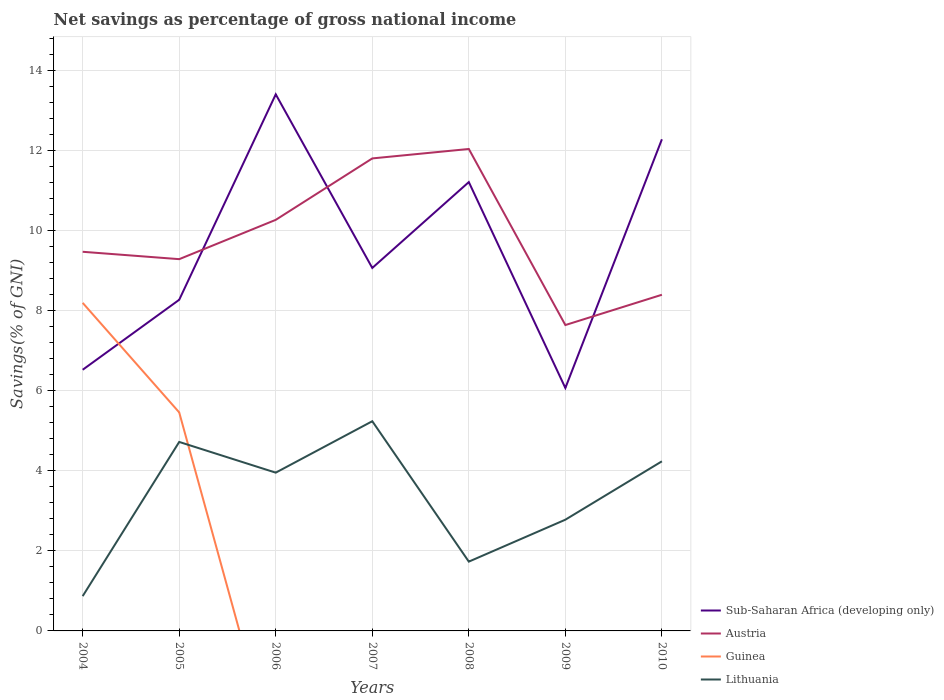How many different coloured lines are there?
Your response must be concise. 4. Is the number of lines equal to the number of legend labels?
Provide a short and direct response. No. Across all years, what is the maximum total savings in Lithuania?
Give a very brief answer. 0.87. What is the total total savings in Sub-Saharan Africa (developing only) in the graph?
Provide a succinct answer. 5.15. What is the difference between the highest and the second highest total savings in Sub-Saharan Africa (developing only)?
Offer a very short reply. 7.34. What is the difference between the highest and the lowest total savings in Sub-Saharan Africa (developing only)?
Make the answer very short. 3. How many lines are there?
Give a very brief answer. 4. How many years are there in the graph?
Provide a succinct answer. 7. What is the difference between two consecutive major ticks on the Y-axis?
Your response must be concise. 2. Are the values on the major ticks of Y-axis written in scientific E-notation?
Offer a very short reply. No. How many legend labels are there?
Offer a very short reply. 4. How are the legend labels stacked?
Your answer should be very brief. Vertical. What is the title of the graph?
Provide a succinct answer. Net savings as percentage of gross national income. Does "Lao PDR" appear as one of the legend labels in the graph?
Ensure brevity in your answer.  No. What is the label or title of the Y-axis?
Provide a succinct answer. Savings(% of GNI). What is the Savings(% of GNI) of Sub-Saharan Africa (developing only) in 2004?
Your answer should be compact. 6.53. What is the Savings(% of GNI) of Austria in 2004?
Offer a terse response. 9.48. What is the Savings(% of GNI) in Guinea in 2004?
Your answer should be compact. 8.2. What is the Savings(% of GNI) of Lithuania in 2004?
Ensure brevity in your answer.  0.87. What is the Savings(% of GNI) of Sub-Saharan Africa (developing only) in 2005?
Your response must be concise. 8.28. What is the Savings(% of GNI) in Austria in 2005?
Your answer should be compact. 9.29. What is the Savings(% of GNI) in Guinea in 2005?
Provide a succinct answer. 5.46. What is the Savings(% of GNI) in Lithuania in 2005?
Make the answer very short. 4.72. What is the Savings(% of GNI) in Sub-Saharan Africa (developing only) in 2006?
Provide a succinct answer. 13.41. What is the Savings(% of GNI) of Austria in 2006?
Your answer should be very brief. 10.27. What is the Savings(% of GNI) in Lithuania in 2006?
Provide a short and direct response. 3.96. What is the Savings(% of GNI) in Sub-Saharan Africa (developing only) in 2007?
Provide a succinct answer. 9.07. What is the Savings(% of GNI) of Austria in 2007?
Provide a short and direct response. 11.81. What is the Savings(% of GNI) of Guinea in 2007?
Your answer should be compact. 0. What is the Savings(% of GNI) in Lithuania in 2007?
Your answer should be compact. 5.24. What is the Savings(% of GNI) in Sub-Saharan Africa (developing only) in 2008?
Make the answer very short. 11.22. What is the Savings(% of GNI) in Austria in 2008?
Offer a terse response. 12.04. What is the Savings(% of GNI) of Lithuania in 2008?
Ensure brevity in your answer.  1.73. What is the Savings(% of GNI) in Sub-Saharan Africa (developing only) in 2009?
Provide a succinct answer. 6.07. What is the Savings(% of GNI) of Austria in 2009?
Your response must be concise. 7.64. What is the Savings(% of GNI) in Lithuania in 2009?
Provide a short and direct response. 2.78. What is the Savings(% of GNI) of Sub-Saharan Africa (developing only) in 2010?
Your response must be concise. 12.29. What is the Savings(% of GNI) in Austria in 2010?
Your answer should be very brief. 8.4. What is the Savings(% of GNI) in Guinea in 2010?
Give a very brief answer. 0. What is the Savings(% of GNI) of Lithuania in 2010?
Your answer should be very brief. 4.24. Across all years, what is the maximum Savings(% of GNI) of Sub-Saharan Africa (developing only)?
Your answer should be very brief. 13.41. Across all years, what is the maximum Savings(% of GNI) of Austria?
Provide a short and direct response. 12.04. Across all years, what is the maximum Savings(% of GNI) in Guinea?
Your response must be concise. 8.2. Across all years, what is the maximum Savings(% of GNI) of Lithuania?
Provide a succinct answer. 5.24. Across all years, what is the minimum Savings(% of GNI) of Sub-Saharan Africa (developing only)?
Ensure brevity in your answer.  6.07. Across all years, what is the minimum Savings(% of GNI) of Austria?
Keep it short and to the point. 7.64. Across all years, what is the minimum Savings(% of GNI) in Guinea?
Ensure brevity in your answer.  0. Across all years, what is the minimum Savings(% of GNI) in Lithuania?
Ensure brevity in your answer.  0.87. What is the total Savings(% of GNI) in Sub-Saharan Africa (developing only) in the graph?
Make the answer very short. 66.86. What is the total Savings(% of GNI) of Austria in the graph?
Your answer should be very brief. 68.94. What is the total Savings(% of GNI) of Guinea in the graph?
Keep it short and to the point. 13.66. What is the total Savings(% of GNI) of Lithuania in the graph?
Ensure brevity in your answer.  23.54. What is the difference between the Savings(% of GNI) of Sub-Saharan Africa (developing only) in 2004 and that in 2005?
Ensure brevity in your answer.  -1.75. What is the difference between the Savings(% of GNI) of Austria in 2004 and that in 2005?
Provide a succinct answer. 0.18. What is the difference between the Savings(% of GNI) in Guinea in 2004 and that in 2005?
Offer a very short reply. 2.74. What is the difference between the Savings(% of GNI) of Lithuania in 2004 and that in 2005?
Offer a very short reply. -3.85. What is the difference between the Savings(% of GNI) in Sub-Saharan Africa (developing only) in 2004 and that in 2006?
Keep it short and to the point. -6.88. What is the difference between the Savings(% of GNI) of Austria in 2004 and that in 2006?
Give a very brief answer. -0.8. What is the difference between the Savings(% of GNI) in Lithuania in 2004 and that in 2006?
Provide a short and direct response. -3.09. What is the difference between the Savings(% of GNI) of Sub-Saharan Africa (developing only) in 2004 and that in 2007?
Give a very brief answer. -2.54. What is the difference between the Savings(% of GNI) in Austria in 2004 and that in 2007?
Provide a short and direct response. -2.33. What is the difference between the Savings(% of GNI) of Lithuania in 2004 and that in 2007?
Offer a very short reply. -4.37. What is the difference between the Savings(% of GNI) of Sub-Saharan Africa (developing only) in 2004 and that in 2008?
Give a very brief answer. -4.69. What is the difference between the Savings(% of GNI) of Austria in 2004 and that in 2008?
Keep it short and to the point. -2.57. What is the difference between the Savings(% of GNI) of Lithuania in 2004 and that in 2008?
Make the answer very short. -0.86. What is the difference between the Savings(% of GNI) of Sub-Saharan Africa (developing only) in 2004 and that in 2009?
Give a very brief answer. 0.46. What is the difference between the Savings(% of GNI) in Austria in 2004 and that in 2009?
Ensure brevity in your answer.  1.83. What is the difference between the Savings(% of GNI) in Lithuania in 2004 and that in 2009?
Make the answer very short. -1.91. What is the difference between the Savings(% of GNI) of Sub-Saharan Africa (developing only) in 2004 and that in 2010?
Offer a terse response. -5.76. What is the difference between the Savings(% of GNI) in Austria in 2004 and that in 2010?
Offer a terse response. 1.07. What is the difference between the Savings(% of GNI) in Lithuania in 2004 and that in 2010?
Offer a very short reply. -3.37. What is the difference between the Savings(% of GNI) in Sub-Saharan Africa (developing only) in 2005 and that in 2006?
Your answer should be very brief. -5.13. What is the difference between the Savings(% of GNI) of Austria in 2005 and that in 2006?
Provide a short and direct response. -0.98. What is the difference between the Savings(% of GNI) of Lithuania in 2005 and that in 2006?
Ensure brevity in your answer.  0.77. What is the difference between the Savings(% of GNI) of Sub-Saharan Africa (developing only) in 2005 and that in 2007?
Offer a terse response. -0.8. What is the difference between the Savings(% of GNI) of Austria in 2005 and that in 2007?
Your response must be concise. -2.52. What is the difference between the Savings(% of GNI) of Lithuania in 2005 and that in 2007?
Your answer should be compact. -0.52. What is the difference between the Savings(% of GNI) in Sub-Saharan Africa (developing only) in 2005 and that in 2008?
Your answer should be compact. -2.94. What is the difference between the Savings(% of GNI) of Austria in 2005 and that in 2008?
Offer a very short reply. -2.75. What is the difference between the Savings(% of GNI) in Lithuania in 2005 and that in 2008?
Give a very brief answer. 2.99. What is the difference between the Savings(% of GNI) in Sub-Saharan Africa (developing only) in 2005 and that in 2009?
Your answer should be compact. 2.21. What is the difference between the Savings(% of GNI) of Austria in 2005 and that in 2009?
Give a very brief answer. 1.65. What is the difference between the Savings(% of GNI) in Lithuania in 2005 and that in 2009?
Provide a succinct answer. 1.94. What is the difference between the Savings(% of GNI) of Sub-Saharan Africa (developing only) in 2005 and that in 2010?
Ensure brevity in your answer.  -4.01. What is the difference between the Savings(% of GNI) of Austria in 2005 and that in 2010?
Your answer should be compact. 0.89. What is the difference between the Savings(% of GNI) of Lithuania in 2005 and that in 2010?
Offer a terse response. 0.48. What is the difference between the Savings(% of GNI) in Sub-Saharan Africa (developing only) in 2006 and that in 2007?
Keep it short and to the point. 4.34. What is the difference between the Savings(% of GNI) in Austria in 2006 and that in 2007?
Provide a succinct answer. -1.54. What is the difference between the Savings(% of GNI) in Lithuania in 2006 and that in 2007?
Provide a succinct answer. -1.29. What is the difference between the Savings(% of GNI) in Sub-Saharan Africa (developing only) in 2006 and that in 2008?
Offer a terse response. 2.19. What is the difference between the Savings(% of GNI) in Austria in 2006 and that in 2008?
Offer a terse response. -1.77. What is the difference between the Savings(% of GNI) of Lithuania in 2006 and that in 2008?
Your answer should be compact. 2.22. What is the difference between the Savings(% of GNI) in Sub-Saharan Africa (developing only) in 2006 and that in 2009?
Provide a succinct answer. 7.34. What is the difference between the Savings(% of GNI) in Austria in 2006 and that in 2009?
Your response must be concise. 2.63. What is the difference between the Savings(% of GNI) of Lithuania in 2006 and that in 2009?
Your response must be concise. 1.18. What is the difference between the Savings(% of GNI) in Sub-Saharan Africa (developing only) in 2006 and that in 2010?
Give a very brief answer. 1.12. What is the difference between the Savings(% of GNI) in Austria in 2006 and that in 2010?
Your answer should be very brief. 1.87. What is the difference between the Savings(% of GNI) in Lithuania in 2006 and that in 2010?
Provide a short and direct response. -0.28. What is the difference between the Savings(% of GNI) of Sub-Saharan Africa (developing only) in 2007 and that in 2008?
Offer a terse response. -2.15. What is the difference between the Savings(% of GNI) in Austria in 2007 and that in 2008?
Offer a terse response. -0.24. What is the difference between the Savings(% of GNI) of Lithuania in 2007 and that in 2008?
Keep it short and to the point. 3.51. What is the difference between the Savings(% of GNI) in Sub-Saharan Africa (developing only) in 2007 and that in 2009?
Provide a short and direct response. 3. What is the difference between the Savings(% of GNI) of Austria in 2007 and that in 2009?
Keep it short and to the point. 4.16. What is the difference between the Savings(% of GNI) of Lithuania in 2007 and that in 2009?
Your answer should be compact. 2.46. What is the difference between the Savings(% of GNI) of Sub-Saharan Africa (developing only) in 2007 and that in 2010?
Ensure brevity in your answer.  -3.22. What is the difference between the Savings(% of GNI) of Austria in 2007 and that in 2010?
Your response must be concise. 3.41. What is the difference between the Savings(% of GNI) of Sub-Saharan Africa (developing only) in 2008 and that in 2009?
Ensure brevity in your answer.  5.15. What is the difference between the Savings(% of GNI) in Austria in 2008 and that in 2009?
Offer a terse response. 4.4. What is the difference between the Savings(% of GNI) of Lithuania in 2008 and that in 2009?
Ensure brevity in your answer.  -1.05. What is the difference between the Savings(% of GNI) in Sub-Saharan Africa (developing only) in 2008 and that in 2010?
Offer a terse response. -1.07. What is the difference between the Savings(% of GNI) in Austria in 2008 and that in 2010?
Provide a succinct answer. 3.64. What is the difference between the Savings(% of GNI) of Lithuania in 2008 and that in 2010?
Your response must be concise. -2.51. What is the difference between the Savings(% of GNI) of Sub-Saharan Africa (developing only) in 2009 and that in 2010?
Keep it short and to the point. -6.22. What is the difference between the Savings(% of GNI) of Austria in 2009 and that in 2010?
Ensure brevity in your answer.  -0.76. What is the difference between the Savings(% of GNI) of Lithuania in 2009 and that in 2010?
Ensure brevity in your answer.  -1.46. What is the difference between the Savings(% of GNI) of Sub-Saharan Africa (developing only) in 2004 and the Savings(% of GNI) of Austria in 2005?
Give a very brief answer. -2.76. What is the difference between the Savings(% of GNI) of Sub-Saharan Africa (developing only) in 2004 and the Savings(% of GNI) of Guinea in 2005?
Ensure brevity in your answer.  1.07. What is the difference between the Savings(% of GNI) in Sub-Saharan Africa (developing only) in 2004 and the Savings(% of GNI) in Lithuania in 2005?
Keep it short and to the point. 1.8. What is the difference between the Savings(% of GNI) of Austria in 2004 and the Savings(% of GNI) of Guinea in 2005?
Offer a terse response. 4.01. What is the difference between the Savings(% of GNI) of Austria in 2004 and the Savings(% of GNI) of Lithuania in 2005?
Offer a terse response. 4.75. What is the difference between the Savings(% of GNI) in Guinea in 2004 and the Savings(% of GNI) in Lithuania in 2005?
Your answer should be very brief. 3.48. What is the difference between the Savings(% of GNI) of Sub-Saharan Africa (developing only) in 2004 and the Savings(% of GNI) of Austria in 2006?
Make the answer very short. -3.75. What is the difference between the Savings(% of GNI) of Sub-Saharan Africa (developing only) in 2004 and the Savings(% of GNI) of Lithuania in 2006?
Provide a short and direct response. 2.57. What is the difference between the Savings(% of GNI) in Austria in 2004 and the Savings(% of GNI) in Lithuania in 2006?
Provide a succinct answer. 5.52. What is the difference between the Savings(% of GNI) in Guinea in 2004 and the Savings(% of GNI) in Lithuania in 2006?
Offer a terse response. 4.24. What is the difference between the Savings(% of GNI) in Sub-Saharan Africa (developing only) in 2004 and the Savings(% of GNI) in Austria in 2007?
Give a very brief answer. -5.28. What is the difference between the Savings(% of GNI) in Sub-Saharan Africa (developing only) in 2004 and the Savings(% of GNI) in Lithuania in 2007?
Your answer should be compact. 1.29. What is the difference between the Savings(% of GNI) of Austria in 2004 and the Savings(% of GNI) of Lithuania in 2007?
Your response must be concise. 4.23. What is the difference between the Savings(% of GNI) of Guinea in 2004 and the Savings(% of GNI) of Lithuania in 2007?
Provide a short and direct response. 2.96. What is the difference between the Savings(% of GNI) of Sub-Saharan Africa (developing only) in 2004 and the Savings(% of GNI) of Austria in 2008?
Offer a terse response. -5.52. What is the difference between the Savings(% of GNI) of Sub-Saharan Africa (developing only) in 2004 and the Savings(% of GNI) of Lithuania in 2008?
Offer a terse response. 4.8. What is the difference between the Savings(% of GNI) of Austria in 2004 and the Savings(% of GNI) of Lithuania in 2008?
Your answer should be very brief. 7.74. What is the difference between the Savings(% of GNI) in Guinea in 2004 and the Savings(% of GNI) in Lithuania in 2008?
Provide a short and direct response. 6.47. What is the difference between the Savings(% of GNI) in Sub-Saharan Africa (developing only) in 2004 and the Savings(% of GNI) in Austria in 2009?
Keep it short and to the point. -1.12. What is the difference between the Savings(% of GNI) of Sub-Saharan Africa (developing only) in 2004 and the Savings(% of GNI) of Lithuania in 2009?
Give a very brief answer. 3.75. What is the difference between the Savings(% of GNI) of Austria in 2004 and the Savings(% of GNI) of Lithuania in 2009?
Your answer should be compact. 6.7. What is the difference between the Savings(% of GNI) of Guinea in 2004 and the Savings(% of GNI) of Lithuania in 2009?
Make the answer very short. 5.42. What is the difference between the Savings(% of GNI) of Sub-Saharan Africa (developing only) in 2004 and the Savings(% of GNI) of Austria in 2010?
Offer a terse response. -1.87. What is the difference between the Savings(% of GNI) in Sub-Saharan Africa (developing only) in 2004 and the Savings(% of GNI) in Lithuania in 2010?
Provide a short and direct response. 2.29. What is the difference between the Savings(% of GNI) of Austria in 2004 and the Savings(% of GNI) of Lithuania in 2010?
Offer a very short reply. 5.24. What is the difference between the Savings(% of GNI) of Guinea in 2004 and the Savings(% of GNI) of Lithuania in 2010?
Keep it short and to the point. 3.96. What is the difference between the Savings(% of GNI) in Sub-Saharan Africa (developing only) in 2005 and the Savings(% of GNI) in Austria in 2006?
Provide a short and direct response. -2. What is the difference between the Savings(% of GNI) in Sub-Saharan Africa (developing only) in 2005 and the Savings(% of GNI) in Lithuania in 2006?
Provide a succinct answer. 4.32. What is the difference between the Savings(% of GNI) in Austria in 2005 and the Savings(% of GNI) in Lithuania in 2006?
Give a very brief answer. 5.34. What is the difference between the Savings(% of GNI) in Guinea in 2005 and the Savings(% of GNI) in Lithuania in 2006?
Your answer should be very brief. 1.51. What is the difference between the Savings(% of GNI) of Sub-Saharan Africa (developing only) in 2005 and the Savings(% of GNI) of Austria in 2007?
Keep it short and to the point. -3.53. What is the difference between the Savings(% of GNI) in Sub-Saharan Africa (developing only) in 2005 and the Savings(% of GNI) in Lithuania in 2007?
Provide a succinct answer. 3.04. What is the difference between the Savings(% of GNI) in Austria in 2005 and the Savings(% of GNI) in Lithuania in 2007?
Offer a very short reply. 4.05. What is the difference between the Savings(% of GNI) in Guinea in 2005 and the Savings(% of GNI) in Lithuania in 2007?
Make the answer very short. 0.22. What is the difference between the Savings(% of GNI) of Sub-Saharan Africa (developing only) in 2005 and the Savings(% of GNI) of Austria in 2008?
Your response must be concise. -3.77. What is the difference between the Savings(% of GNI) in Sub-Saharan Africa (developing only) in 2005 and the Savings(% of GNI) in Lithuania in 2008?
Provide a short and direct response. 6.54. What is the difference between the Savings(% of GNI) in Austria in 2005 and the Savings(% of GNI) in Lithuania in 2008?
Your answer should be very brief. 7.56. What is the difference between the Savings(% of GNI) of Guinea in 2005 and the Savings(% of GNI) of Lithuania in 2008?
Offer a terse response. 3.73. What is the difference between the Savings(% of GNI) in Sub-Saharan Africa (developing only) in 2005 and the Savings(% of GNI) in Austria in 2009?
Your response must be concise. 0.63. What is the difference between the Savings(% of GNI) of Sub-Saharan Africa (developing only) in 2005 and the Savings(% of GNI) of Lithuania in 2009?
Provide a succinct answer. 5.5. What is the difference between the Savings(% of GNI) of Austria in 2005 and the Savings(% of GNI) of Lithuania in 2009?
Your answer should be very brief. 6.51. What is the difference between the Savings(% of GNI) in Guinea in 2005 and the Savings(% of GNI) in Lithuania in 2009?
Make the answer very short. 2.68. What is the difference between the Savings(% of GNI) in Sub-Saharan Africa (developing only) in 2005 and the Savings(% of GNI) in Austria in 2010?
Make the answer very short. -0.13. What is the difference between the Savings(% of GNI) of Sub-Saharan Africa (developing only) in 2005 and the Savings(% of GNI) of Lithuania in 2010?
Provide a succinct answer. 4.04. What is the difference between the Savings(% of GNI) of Austria in 2005 and the Savings(% of GNI) of Lithuania in 2010?
Your response must be concise. 5.05. What is the difference between the Savings(% of GNI) in Guinea in 2005 and the Savings(% of GNI) in Lithuania in 2010?
Your answer should be compact. 1.22. What is the difference between the Savings(% of GNI) of Sub-Saharan Africa (developing only) in 2006 and the Savings(% of GNI) of Austria in 2007?
Give a very brief answer. 1.6. What is the difference between the Savings(% of GNI) in Sub-Saharan Africa (developing only) in 2006 and the Savings(% of GNI) in Lithuania in 2007?
Make the answer very short. 8.17. What is the difference between the Savings(% of GNI) of Austria in 2006 and the Savings(% of GNI) of Lithuania in 2007?
Make the answer very short. 5.03. What is the difference between the Savings(% of GNI) in Sub-Saharan Africa (developing only) in 2006 and the Savings(% of GNI) in Austria in 2008?
Ensure brevity in your answer.  1.37. What is the difference between the Savings(% of GNI) in Sub-Saharan Africa (developing only) in 2006 and the Savings(% of GNI) in Lithuania in 2008?
Offer a very short reply. 11.68. What is the difference between the Savings(% of GNI) in Austria in 2006 and the Savings(% of GNI) in Lithuania in 2008?
Your answer should be very brief. 8.54. What is the difference between the Savings(% of GNI) in Sub-Saharan Africa (developing only) in 2006 and the Savings(% of GNI) in Austria in 2009?
Your response must be concise. 5.77. What is the difference between the Savings(% of GNI) of Sub-Saharan Africa (developing only) in 2006 and the Savings(% of GNI) of Lithuania in 2009?
Provide a succinct answer. 10.63. What is the difference between the Savings(% of GNI) of Austria in 2006 and the Savings(% of GNI) of Lithuania in 2009?
Keep it short and to the point. 7.49. What is the difference between the Savings(% of GNI) in Sub-Saharan Africa (developing only) in 2006 and the Savings(% of GNI) in Austria in 2010?
Make the answer very short. 5.01. What is the difference between the Savings(% of GNI) of Sub-Saharan Africa (developing only) in 2006 and the Savings(% of GNI) of Lithuania in 2010?
Make the answer very short. 9.17. What is the difference between the Savings(% of GNI) of Austria in 2006 and the Savings(% of GNI) of Lithuania in 2010?
Ensure brevity in your answer.  6.03. What is the difference between the Savings(% of GNI) in Sub-Saharan Africa (developing only) in 2007 and the Savings(% of GNI) in Austria in 2008?
Give a very brief answer. -2.97. What is the difference between the Savings(% of GNI) of Sub-Saharan Africa (developing only) in 2007 and the Savings(% of GNI) of Lithuania in 2008?
Give a very brief answer. 7.34. What is the difference between the Savings(% of GNI) in Austria in 2007 and the Savings(% of GNI) in Lithuania in 2008?
Give a very brief answer. 10.08. What is the difference between the Savings(% of GNI) in Sub-Saharan Africa (developing only) in 2007 and the Savings(% of GNI) in Austria in 2009?
Your answer should be compact. 1.43. What is the difference between the Savings(% of GNI) of Sub-Saharan Africa (developing only) in 2007 and the Savings(% of GNI) of Lithuania in 2009?
Give a very brief answer. 6.29. What is the difference between the Savings(% of GNI) in Austria in 2007 and the Savings(% of GNI) in Lithuania in 2009?
Keep it short and to the point. 9.03. What is the difference between the Savings(% of GNI) in Sub-Saharan Africa (developing only) in 2007 and the Savings(% of GNI) in Austria in 2010?
Your answer should be compact. 0.67. What is the difference between the Savings(% of GNI) of Sub-Saharan Africa (developing only) in 2007 and the Savings(% of GNI) of Lithuania in 2010?
Keep it short and to the point. 4.83. What is the difference between the Savings(% of GNI) of Austria in 2007 and the Savings(% of GNI) of Lithuania in 2010?
Your response must be concise. 7.57. What is the difference between the Savings(% of GNI) of Sub-Saharan Africa (developing only) in 2008 and the Savings(% of GNI) of Austria in 2009?
Make the answer very short. 3.57. What is the difference between the Savings(% of GNI) of Sub-Saharan Africa (developing only) in 2008 and the Savings(% of GNI) of Lithuania in 2009?
Provide a succinct answer. 8.44. What is the difference between the Savings(% of GNI) in Austria in 2008 and the Savings(% of GNI) in Lithuania in 2009?
Make the answer very short. 9.26. What is the difference between the Savings(% of GNI) in Sub-Saharan Africa (developing only) in 2008 and the Savings(% of GNI) in Austria in 2010?
Provide a short and direct response. 2.82. What is the difference between the Savings(% of GNI) of Sub-Saharan Africa (developing only) in 2008 and the Savings(% of GNI) of Lithuania in 2010?
Your answer should be very brief. 6.98. What is the difference between the Savings(% of GNI) in Austria in 2008 and the Savings(% of GNI) in Lithuania in 2010?
Provide a succinct answer. 7.81. What is the difference between the Savings(% of GNI) in Sub-Saharan Africa (developing only) in 2009 and the Savings(% of GNI) in Austria in 2010?
Provide a short and direct response. -2.33. What is the difference between the Savings(% of GNI) in Sub-Saharan Africa (developing only) in 2009 and the Savings(% of GNI) in Lithuania in 2010?
Keep it short and to the point. 1.83. What is the difference between the Savings(% of GNI) in Austria in 2009 and the Savings(% of GNI) in Lithuania in 2010?
Provide a short and direct response. 3.41. What is the average Savings(% of GNI) in Sub-Saharan Africa (developing only) per year?
Provide a short and direct response. 9.55. What is the average Savings(% of GNI) in Austria per year?
Keep it short and to the point. 9.85. What is the average Savings(% of GNI) in Guinea per year?
Your answer should be very brief. 1.95. What is the average Savings(% of GNI) in Lithuania per year?
Your answer should be compact. 3.36. In the year 2004, what is the difference between the Savings(% of GNI) in Sub-Saharan Africa (developing only) and Savings(% of GNI) in Austria?
Ensure brevity in your answer.  -2.95. In the year 2004, what is the difference between the Savings(% of GNI) of Sub-Saharan Africa (developing only) and Savings(% of GNI) of Guinea?
Your answer should be compact. -1.67. In the year 2004, what is the difference between the Savings(% of GNI) of Sub-Saharan Africa (developing only) and Savings(% of GNI) of Lithuania?
Offer a terse response. 5.66. In the year 2004, what is the difference between the Savings(% of GNI) in Austria and Savings(% of GNI) in Guinea?
Give a very brief answer. 1.28. In the year 2004, what is the difference between the Savings(% of GNI) of Austria and Savings(% of GNI) of Lithuania?
Provide a short and direct response. 8.61. In the year 2004, what is the difference between the Savings(% of GNI) in Guinea and Savings(% of GNI) in Lithuania?
Your answer should be very brief. 7.33. In the year 2005, what is the difference between the Savings(% of GNI) in Sub-Saharan Africa (developing only) and Savings(% of GNI) in Austria?
Give a very brief answer. -1.01. In the year 2005, what is the difference between the Savings(% of GNI) in Sub-Saharan Africa (developing only) and Savings(% of GNI) in Guinea?
Ensure brevity in your answer.  2.82. In the year 2005, what is the difference between the Savings(% of GNI) of Sub-Saharan Africa (developing only) and Savings(% of GNI) of Lithuania?
Keep it short and to the point. 3.55. In the year 2005, what is the difference between the Savings(% of GNI) in Austria and Savings(% of GNI) in Guinea?
Offer a terse response. 3.83. In the year 2005, what is the difference between the Savings(% of GNI) of Austria and Savings(% of GNI) of Lithuania?
Provide a succinct answer. 4.57. In the year 2005, what is the difference between the Savings(% of GNI) of Guinea and Savings(% of GNI) of Lithuania?
Make the answer very short. 0.74. In the year 2006, what is the difference between the Savings(% of GNI) in Sub-Saharan Africa (developing only) and Savings(% of GNI) in Austria?
Give a very brief answer. 3.14. In the year 2006, what is the difference between the Savings(% of GNI) of Sub-Saharan Africa (developing only) and Savings(% of GNI) of Lithuania?
Provide a succinct answer. 9.45. In the year 2006, what is the difference between the Savings(% of GNI) in Austria and Savings(% of GNI) in Lithuania?
Make the answer very short. 6.32. In the year 2007, what is the difference between the Savings(% of GNI) of Sub-Saharan Africa (developing only) and Savings(% of GNI) of Austria?
Keep it short and to the point. -2.74. In the year 2007, what is the difference between the Savings(% of GNI) of Sub-Saharan Africa (developing only) and Savings(% of GNI) of Lithuania?
Offer a very short reply. 3.83. In the year 2007, what is the difference between the Savings(% of GNI) of Austria and Savings(% of GNI) of Lithuania?
Your response must be concise. 6.57. In the year 2008, what is the difference between the Savings(% of GNI) in Sub-Saharan Africa (developing only) and Savings(% of GNI) in Austria?
Provide a succinct answer. -0.83. In the year 2008, what is the difference between the Savings(% of GNI) in Sub-Saharan Africa (developing only) and Savings(% of GNI) in Lithuania?
Your answer should be very brief. 9.49. In the year 2008, what is the difference between the Savings(% of GNI) of Austria and Savings(% of GNI) of Lithuania?
Your answer should be compact. 10.31. In the year 2009, what is the difference between the Savings(% of GNI) of Sub-Saharan Africa (developing only) and Savings(% of GNI) of Austria?
Provide a short and direct response. -1.57. In the year 2009, what is the difference between the Savings(% of GNI) in Sub-Saharan Africa (developing only) and Savings(% of GNI) in Lithuania?
Offer a very short reply. 3.29. In the year 2009, what is the difference between the Savings(% of GNI) of Austria and Savings(% of GNI) of Lithuania?
Offer a terse response. 4.86. In the year 2010, what is the difference between the Savings(% of GNI) in Sub-Saharan Africa (developing only) and Savings(% of GNI) in Austria?
Provide a succinct answer. 3.89. In the year 2010, what is the difference between the Savings(% of GNI) of Sub-Saharan Africa (developing only) and Savings(% of GNI) of Lithuania?
Make the answer very short. 8.05. In the year 2010, what is the difference between the Savings(% of GNI) of Austria and Savings(% of GNI) of Lithuania?
Provide a succinct answer. 4.16. What is the ratio of the Savings(% of GNI) in Sub-Saharan Africa (developing only) in 2004 to that in 2005?
Your answer should be very brief. 0.79. What is the ratio of the Savings(% of GNI) of Austria in 2004 to that in 2005?
Offer a terse response. 1.02. What is the ratio of the Savings(% of GNI) of Guinea in 2004 to that in 2005?
Make the answer very short. 1.5. What is the ratio of the Savings(% of GNI) of Lithuania in 2004 to that in 2005?
Your answer should be compact. 0.18. What is the ratio of the Savings(% of GNI) of Sub-Saharan Africa (developing only) in 2004 to that in 2006?
Your answer should be compact. 0.49. What is the ratio of the Savings(% of GNI) in Austria in 2004 to that in 2006?
Provide a short and direct response. 0.92. What is the ratio of the Savings(% of GNI) of Lithuania in 2004 to that in 2006?
Provide a short and direct response. 0.22. What is the ratio of the Savings(% of GNI) of Sub-Saharan Africa (developing only) in 2004 to that in 2007?
Offer a terse response. 0.72. What is the ratio of the Savings(% of GNI) of Austria in 2004 to that in 2007?
Your response must be concise. 0.8. What is the ratio of the Savings(% of GNI) of Lithuania in 2004 to that in 2007?
Your response must be concise. 0.17. What is the ratio of the Savings(% of GNI) in Sub-Saharan Africa (developing only) in 2004 to that in 2008?
Your response must be concise. 0.58. What is the ratio of the Savings(% of GNI) in Austria in 2004 to that in 2008?
Make the answer very short. 0.79. What is the ratio of the Savings(% of GNI) in Lithuania in 2004 to that in 2008?
Provide a succinct answer. 0.5. What is the ratio of the Savings(% of GNI) in Sub-Saharan Africa (developing only) in 2004 to that in 2009?
Your answer should be very brief. 1.08. What is the ratio of the Savings(% of GNI) of Austria in 2004 to that in 2009?
Keep it short and to the point. 1.24. What is the ratio of the Savings(% of GNI) in Lithuania in 2004 to that in 2009?
Your answer should be very brief. 0.31. What is the ratio of the Savings(% of GNI) of Sub-Saharan Africa (developing only) in 2004 to that in 2010?
Offer a terse response. 0.53. What is the ratio of the Savings(% of GNI) of Austria in 2004 to that in 2010?
Your answer should be very brief. 1.13. What is the ratio of the Savings(% of GNI) in Lithuania in 2004 to that in 2010?
Offer a very short reply. 0.2. What is the ratio of the Savings(% of GNI) in Sub-Saharan Africa (developing only) in 2005 to that in 2006?
Your answer should be very brief. 0.62. What is the ratio of the Savings(% of GNI) of Austria in 2005 to that in 2006?
Your answer should be compact. 0.9. What is the ratio of the Savings(% of GNI) of Lithuania in 2005 to that in 2006?
Your answer should be very brief. 1.19. What is the ratio of the Savings(% of GNI) of Sub-Saharan Africa (developing only) in 2005 to that in 2007?
Keep it short and to the point. 0.91. What is the ratio of the Savings(% of GNI) in Austria in 2005 to that in 2007?
Your response must be concise. 0.79. What is the ratio of the Savings(% of GNI) in Lithuania in 2005 to that in 2007?
Give a very brief answer. 0.9. What is the ratio of the Savings(% of GNI) in Sub-Saharan Africa (developing only) in 2005 to that in 2008?
Offer a very short reply. 0.74. What is the ratio of the Savings(% of GNI) of Austria in 2005 to that in 2008?
Your response must be concise. 0.77. What is the ratio of the Savings(% of GNI) in Lithuania in 2005 to that in 2008?
Make the answer very short. 2.73. What is the ratio of the Savings(% of GNI) in Sub-Saharan Africa (developing only) in 2005 to that in 2009?
Give a very brief answer. 1.36. What is the ratio of the Savings(% of GNI) in Austria in 2005 to that in 2009?
Your answer should be compact. 1.22. What is the ratio of the Savings(% of GNI) of Lithuania in 2005 to that in 2009?
Make the answer very short. 1.7. What is the ratio of the Savings(% of GNI) of Sub-Saharan Africa (developing only) in 2005 to that in 2010?
Your answer should be compact. 0.67. What is the ratio of the Savings(% of GNI) in Austria in 2005 to that in 2010?
Ensure brevity in your answer.  1.11. What is the ratio of the Savings(% of GNI) of Lithuania in 2005 to that in 2010?
Provide a succinct answer. 1.11. What is the ratio of the Savings(% of GNI) in Sub-Saharan Africa (developing only) in 2006 to that in 2007?
Ensure brevity in your answer.  1.48. What is the ratio of the Savings(% of GNI) of Austria in 2006 to that in 2007?
Your answer should be compact. 0.87. What is the ratio of the Savings(% of GNI) in Lithuania in 2006 to that in 2007?
Provide a succinct answer. 0.75. What is the ratio of the Savings(% of GNI) of Sub-Saharan Africa (developing only) in 2006 to that in 2008?
Ensure brevity in your answer.  1.2. What is the ratio of the Savings(% of GNI) of Austria in 2006 to that in 2008?
Your answer should be compact. 0.85. What is the ratio of the Savings(% of GNI) in Lithuania in 2006 to that in 2008?
Your answer should be very brief. 2.28. What is the ratio of the Savings(% of GNI) of Sub-Saharan Africa (developing only) in 2006 to that in 2009?
Make the answer very short. 2.21. What is the ratio of the Savings(% of GNI) of Austria in 2006 to that in 2009?
Offer a terse response. 1.34. What is the ratio of the Savings(% of GNI) of Lithuania in 2006 to that in 2009?
Offer a terse response. 1.42. What is the ratio of the Savings(% of GNI) in Sub-Saharan Africa (developing only) in 2006 to that in 2010?
Your answer should be very brief. 1.09. What is the ratio of the Savings(% of GNI) of Austria in 2006 to that in 2010?
Offer a terse response. 1.22. What is the ratio of the Savings(% of GNI) in Lithuania in 2006 to that in 2010?
Your answer should be very brief. 0.93. What is the ratio of the Savings(% of GNI) in Sub-Saharan Africa (developing only) in 2007 to that in 2008?
Offer a terse response. 0.81. What is the ratio of the Savings(% of GNI) in Austria in 2007 to that in 2008?
Make the answer very short. 0.98. What is the ratio of the Savings(% of GNI) in Lithuania in 2007 to that in 2008?
Keep it short and to the point. 3.03. What is the ratio of the Savings(% of GNI) in Sub-Saharan Africa (developing only) in 2007 to that in 2009?
Make the answer very short. 1.49. What is the ratio of the Savings(% of GNI) of Austria in 2007 to that in 2009?
Make the answer very short. 1.54. What is the ratio of the Savings(% of GNI) of Lithuania in 2007 to that in 2009?
Your answer should be compact. 1.89. What is the ratio of the Savings(% of GNI) of Sub-Saharan Africa (developing only) in 2007 to that in 2010?
Your answer should be very brief. 0.74. What is the ratio of the Savings(% of GNI) of Austria in 2007 to that in 2010?
Offer a terse response. 1.41. What is the ratio of the Savings(% of GNI) in Lithuania in 2007 to that in 2010?
Give a very brief answer. 1.24. What is the ratio of the Savings(% of GNI) of Sub-Saharan Africa (developing only) in 2008 to that in 2009?
Your answer should be very brief. 1.85. What is the ratio of the Savings(% of GNI) of Austria in 2008 to that in 2009?
Ensure brevity in your answer.  1.58. What is the ratio of the Savings(% of GNI) of Lithuania in 2008 to that in 2009?
Offer a very short reply. 0.62. What is the ratio of the Savings(% of GNI) of Sub-Saharan Africa (developing only) in 2008 to that in 2010?
Provide a succinct answer. 0.91. What is the ratio of the Savings(% of GNI) of Austria in 2008 to that in 2010?
Offer a very short reply. 1.43. What is the ratio of the Savings(% of GNI) in Lithuania in 2008 to that in 2010?
Give a very brief answer. 0.41. What is the ratio of the Savings(% of GNI) of Sub-Saharan Africa (developing only) in 2009 to that in 2010?
Provide a succinct answer. 0.49. What is the ratio of the Savings(% of GNI) in Austria in 2009 to that in 2010?
Provide a short and direct response. 0.91. What is the ratio of the Savings(% of GNI) of Lithuania in 2009 to that in 2010?
Provide a succinct answer. 0.66. What is the difference between the highest and the second highest Savings(% of GNI) in Sub-Saharan Africa (developing only)?
Your answer should be compact. 1.12. What is the difference between the highest and the second highest Savings(% of GNI) in Austria?
Your answer should be compact. 0.24. What is the difference between the highest and the second highest Savings(% of GNI) in Lithuania?
Your response must be concise. 0.52. What is the difference between the highest and the lowest Savings(% of GNI) in Sub-Saharan Africa (developing only)?
Your answer should be very brief. 7.34. What is the difference between the highest and the lowest Savings(% of GNI) in Austria?
Provide a succinct answer. 4.4. What is the difference between the highest and the lowest Savings(% of GNI) in Guinea?
Offer a very short reply. 8.2. What is the difference between the highest and the lowest Savings(% of GNI) of Lithuania?
Your answer should be compact. 4.37. 